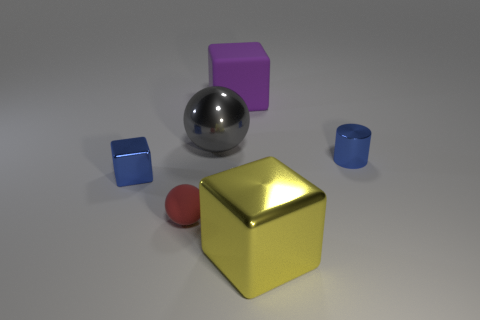Add 3 shiny cubes. How many objects exist? 9 Subtract all spheres. How many objects are left? 4 Add 4 yellow metal cubes. How many yellow metal cubes exist? 5 Subtract 0 gray blocks. How many objects are left? 6 Subtract all metallic spheres. Subtract all small cyan shiny cylinders. How many objects are left? 5 Add 2 matte balls. How many matte balls are left? 3 